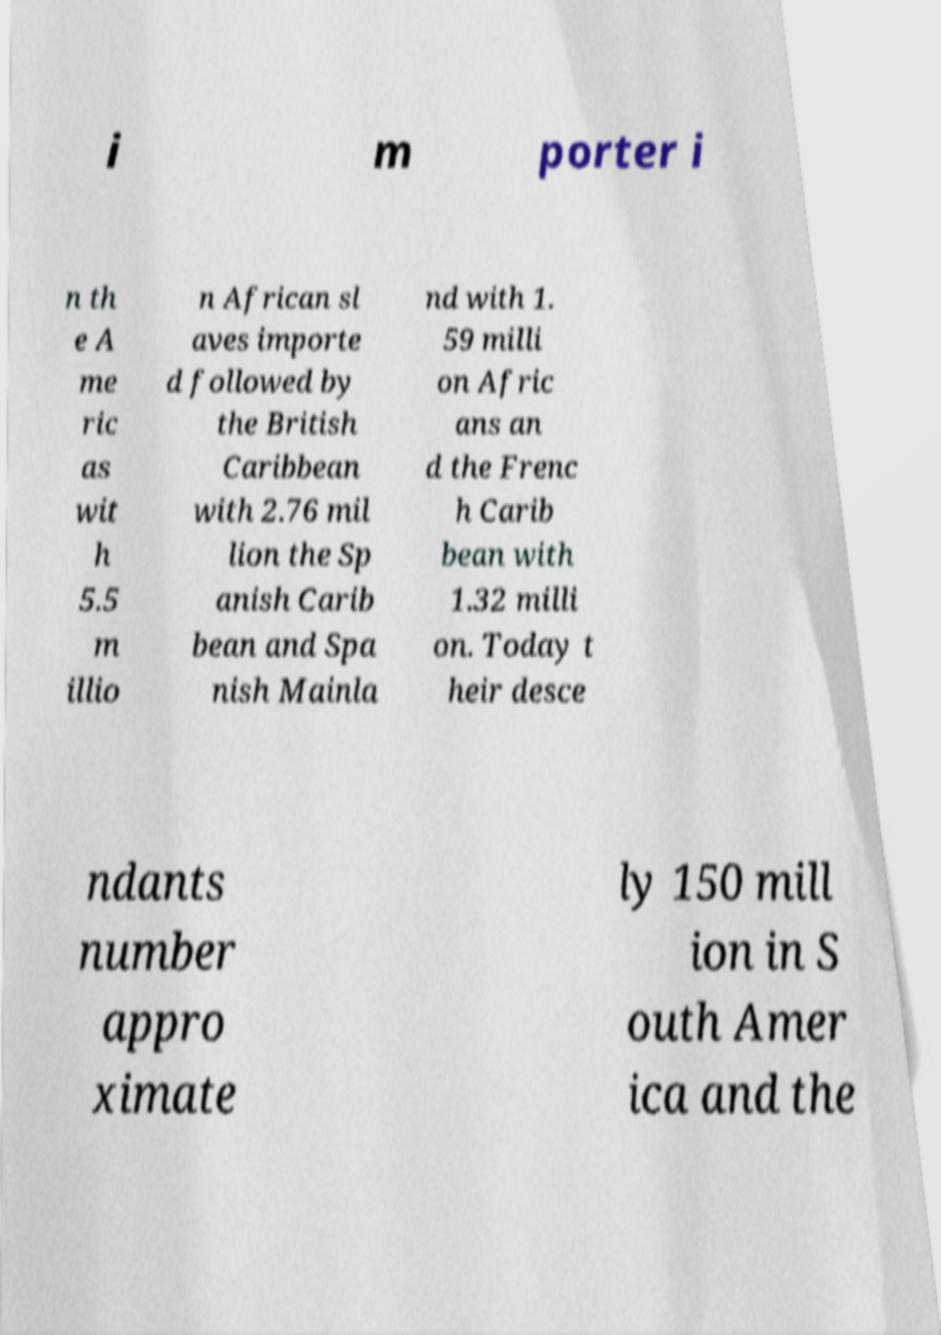Could you extract and type out the text from this image? i m porter i n th e A me ric as wit h 5.5 m illio n African sl aves importe d followed by the British Caribbean with 2.76 mil lion the Sp anish Carib bean and Spa nish Mainla nd with 1. 59 milli on Afric ans an d the Frenc h Carib bean with 1.32 milli on. Today t heir desce ndants number appro ximate ly 150 mill ion in S outh Amer ica and the 